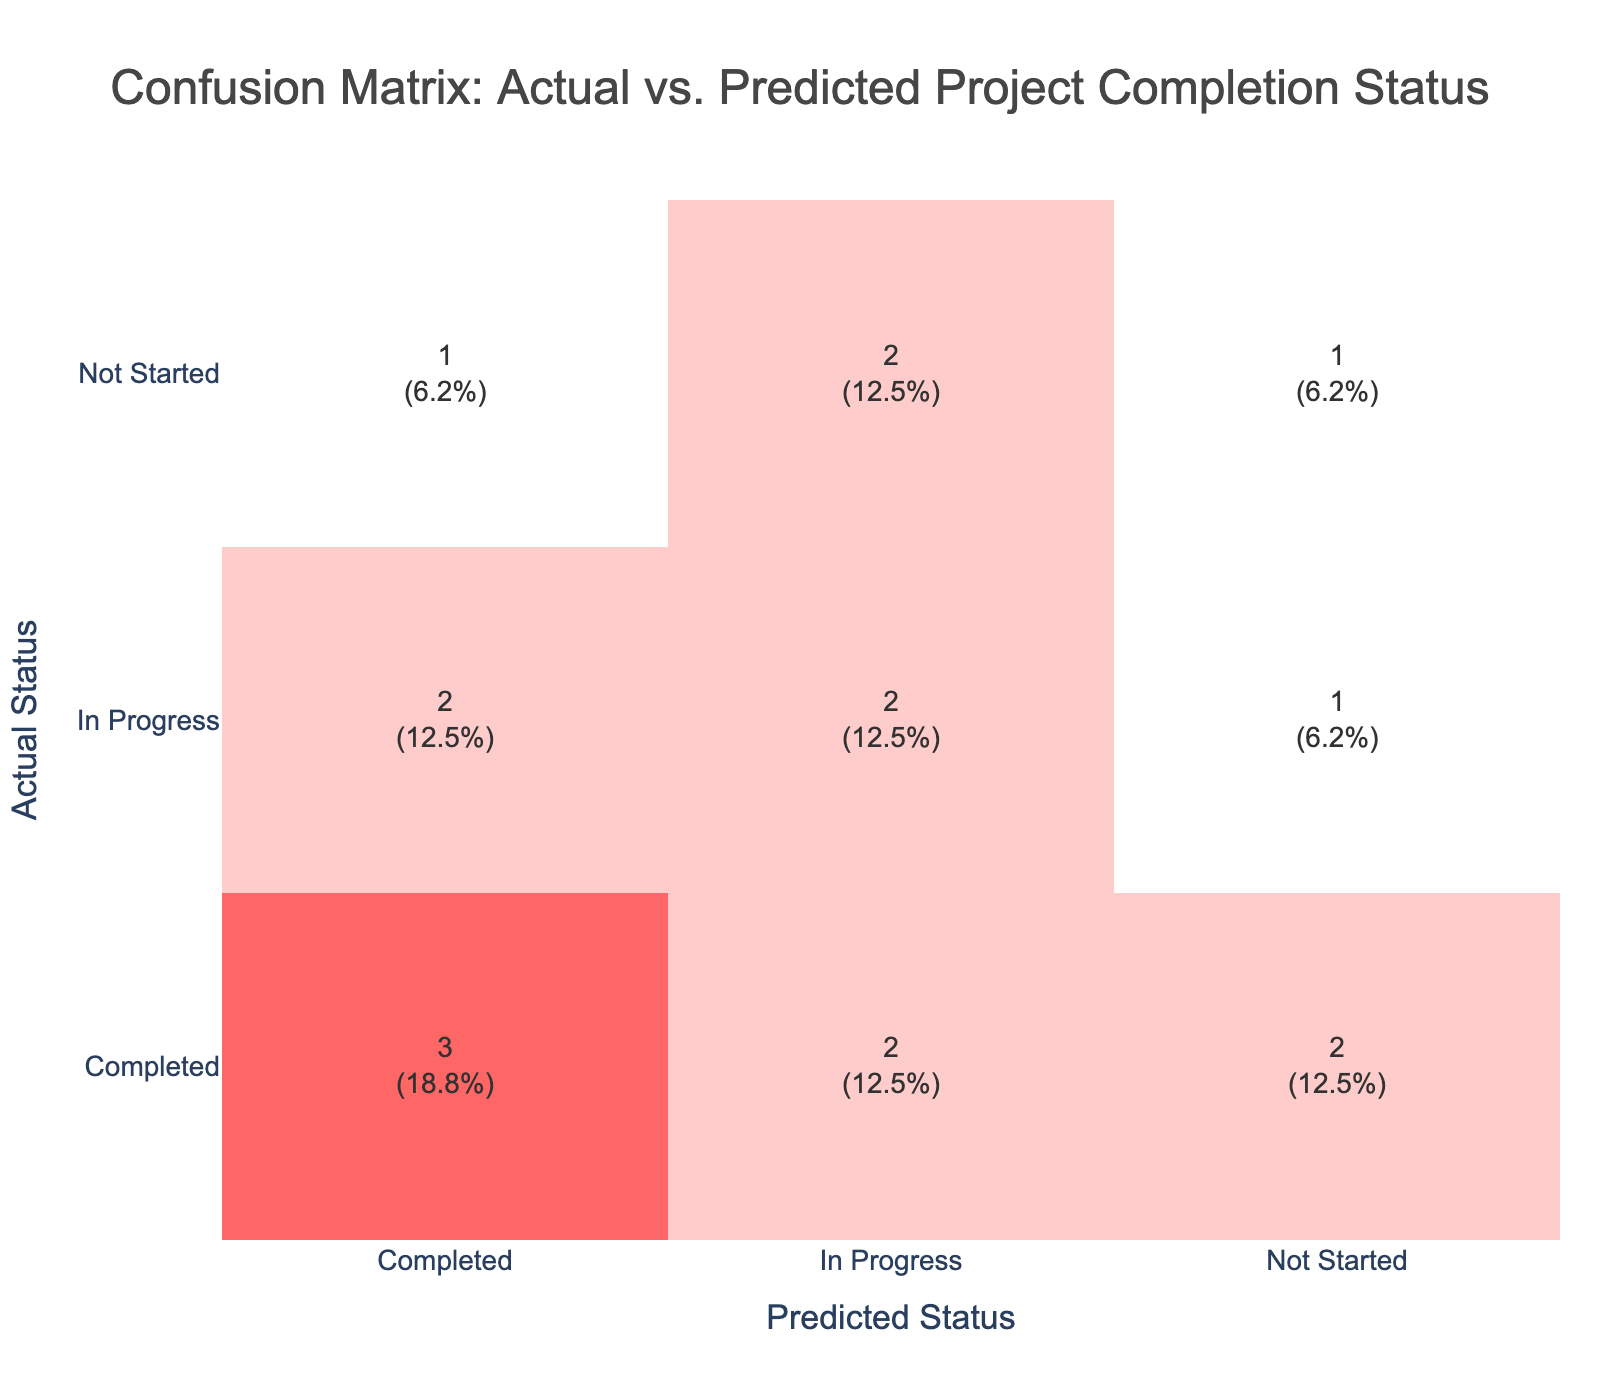What is the count of actual statuses that were correctly predicted as "Completed"? The matrix shows a count of 6 in the cell where both actual and predicted statuses are "Completed."
Answer: 6 What is the total count of instances where the actual status was "In Progress"? To find this, we look at the row for "In Progress" in the actual status section. We add the counts of all predicted statuses under "In Progress," which are: 4 (In Progress) + 2 (Completed) + 2 (Not Started) = 8.
Answer: 8 How many times was "Not Started" predicted when the actual status was "Completed"? In the confusion matrix, we check the row for "Completed" and the column for "Not Started." The value in that cell shows that it happened 2 times.
Answer: 2 What is the percentage of instances that were correctly predicted as "In Progress"? To calculate this, we take the count of "In Progress" predicted accurately, which is 4, divided by the total instances (which is 15), and multiply by 100: (4 / 15) * 100 = 26.67%.
Answer: 26.67% Is it true that there were no cases where "Not Started" was correctly predicted? Checking the confusion matrix, we see the count in the row for "Not Started" and column for "Not Started" is 3. This indicates that there were cases where "Not Started" was indeed predicted correctly.
Answer: No What is the difference between the counts of "Completed" predicted and "Not Started" predicted for the actual status "In Progress"? The count of "In Progress" predicted is 4 and the count of "Not Started" predicted is 2 for the actual status "In Progress." Therefore, the difference is 4 - 2 = 2.
Answer: 2 How many total predictions were made for the "Not Started" actual status? Adding the counts from the "Not Started" row gives us: 3 (Not Started) + 1 (Completed) + 2 (In Progress) = 6.
Answer: 6 Which actual status had the highest incorrect predictions? After looking at each row, the "In Progress" status has incorrect predictions of 2 (predicted as Completed) and 2 (predicted as Not Started), summing to 4. Hence, "In Progress" has the highest incorrect predictions.
Answer: In Progress What is the average percentage of correct predictions across all statuses? The counts of correct predictions are: 6 (Completed), 4 (In Progress), and 3 (Not Started), totaling 13 correct predictions out of 15 total. The average percentage is (13/15)*100 = 86.67%.
Answer: 86.67% 